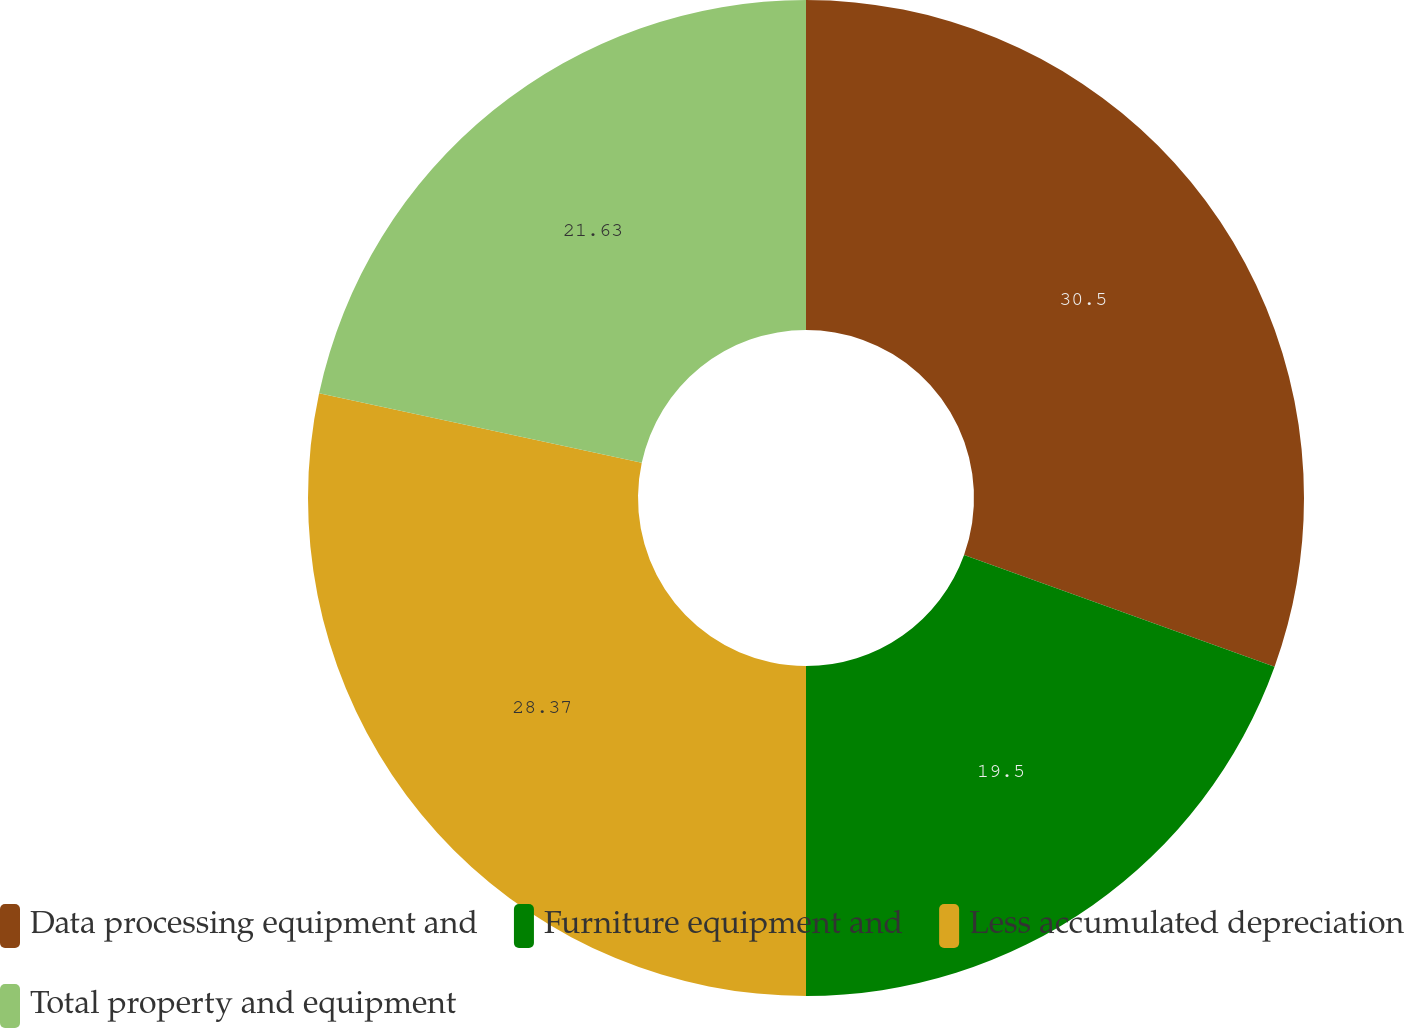Convert chart to OTSL. <chart><loc_0><loc_0><loc_500><loc_500><pie_chart><fcel>Data processing equipment and<fcel>Furniture equipment and<fcel>Less accumulated depreciation<fcel>Total property and equipment<nl><fcel>30.5%<fcel>19.5%<fcel>28.37%<fcel>21.63%<nl></chart> 